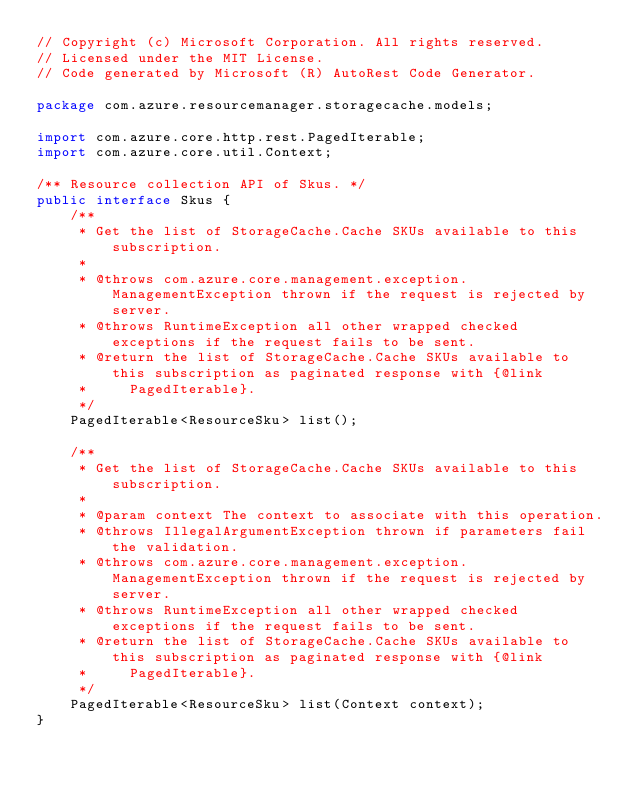Convert code to text. <code><loc_0><loc_0><loc_500><loc_500><_Java_>// Copyright (c) Microsoft Corporation. All rights reserved.
// Licensed under the MIT License.
// Code generated by Microsoft (R) AutoRest Code Generator.

package com.azure.resourcemanager.storagecache.models;

import com.azure.core.http.rest.PagedIterable;
import com.azure.core.util.Context;

/** Resource collection API of Skus. */
public interface Skus {
    /**
     * Get the list of StorageCache.Cache SKUs available to this subscription.
     *
     * @throws com.azure.core.management.exception.ManagementException thrown if the request is rejected by server.
     * @throws RuntimeException all other wrapped checked exceptions if the request fails to be sent.
     * @return the list of StorageCache.Cache SKUs available to this subscription as paginated response with {@link
     *     PagedIterable}.
     */
    PagedIterable<ResourceSku> list();

    /**
     * Get the list of StorageCache.Cache SKUs available to this subscription.
     *
     * @param context The context to associate with this operation.
     * @throws IllegalArgumentException thrown if parameters fail the validation.
     * @throws com.azure.core.management.exception.ManagementException thrown if the request is rejected by server.
     * @throws RuntimeException all other wrapped checked exceptions if the request fails to be sent.
     * @return the list of StorageCache.Cache SKUs available to this subscription as paginated response with {@link
     *     PagedIterable}.
     */
    PagedIterable<ResourceSku> list(Context context);
}
</code> 